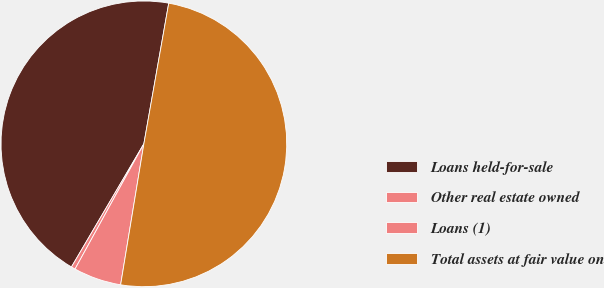Convert chart to OTSL. <chart><loc_0><loc_0><loc_500><loc_500><pie_chart><fcel>Loans held-for-sale<fcel>Other real estate owned<fcel>Loans (1)<fcel>Total assets at fair value on<nl><fcel>44.33%<fcel>0.46%<fcel>5.4%<fcel>49.82%<nl></chart> 